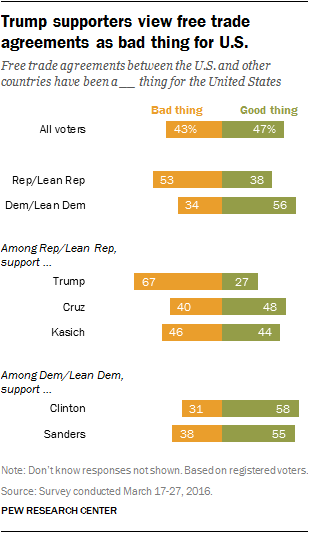Indicate a few pertinent items in this graphic. Orange bar says "Bad thing. What is the distribution of positive and negative traits among all voters? The test results reveal that [47, 43] percentages of voters possess good traits, while [53, 47] percentages of voters exhibit negative traits. 